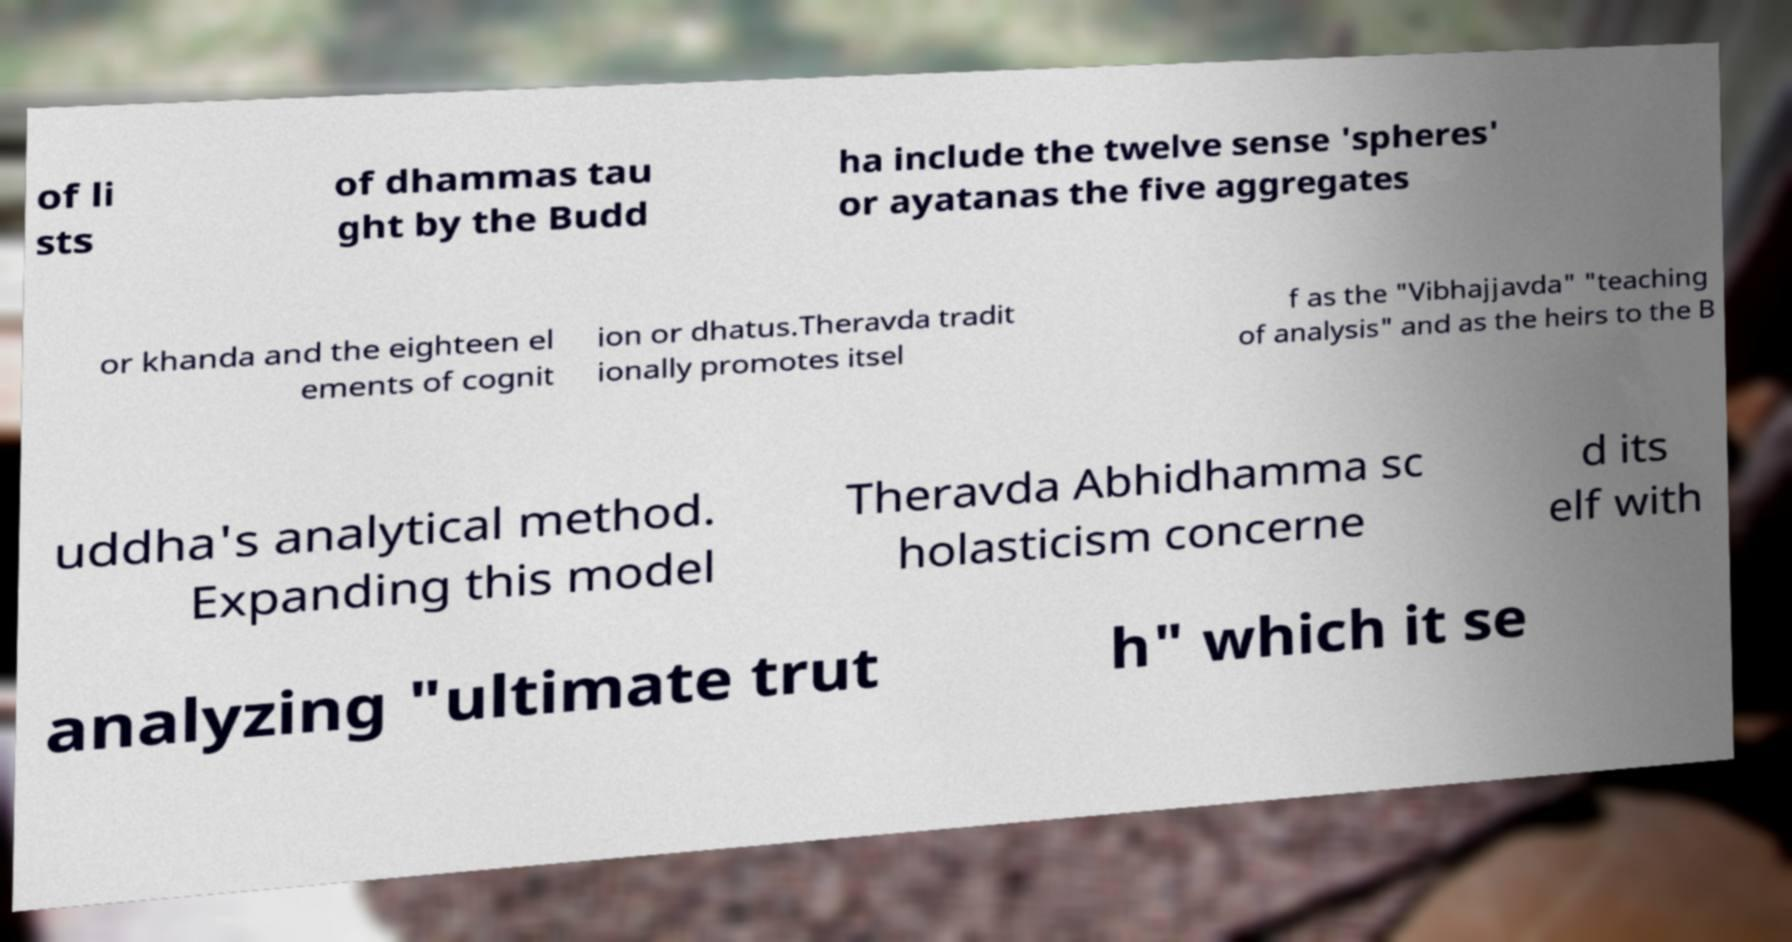Can you accurately transcribe the text from the provided image for me? of li sts of dhammas tau ght by the Budd ha include the twelve sense 'spheres' or ayatanas the five aggregates or khanda and the eighteen el ements of cognit ion or dhatus.Theravda tradit ionally promotes itsel f as the "Vibhajjavda" "teaching of analysis" and as the heirs to the B uddha's analytical method. Expanding this model Theravda Abhidhamma sc holasticism concerne d its elf with analyzing "ultimate trut h" which it se 